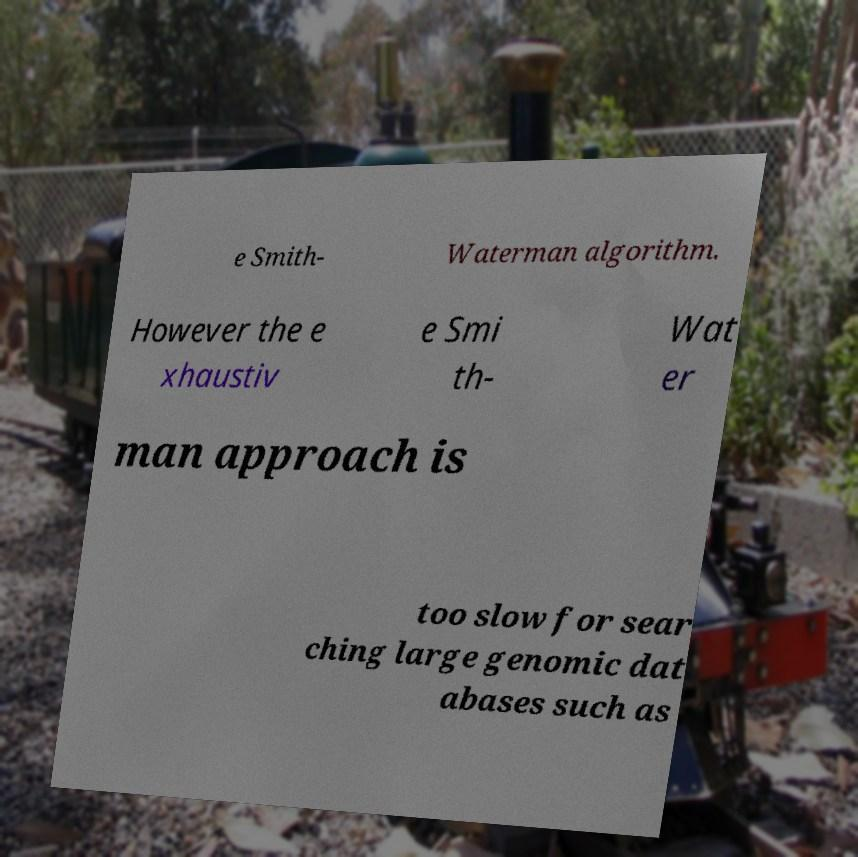Can you accurately transcribe the text from the provided image for me? e Smith- Waterman algorithm. However the e xhaustiv e Smi th- Wat er man approach is too slow for sear ching large genomic dat abases such as 